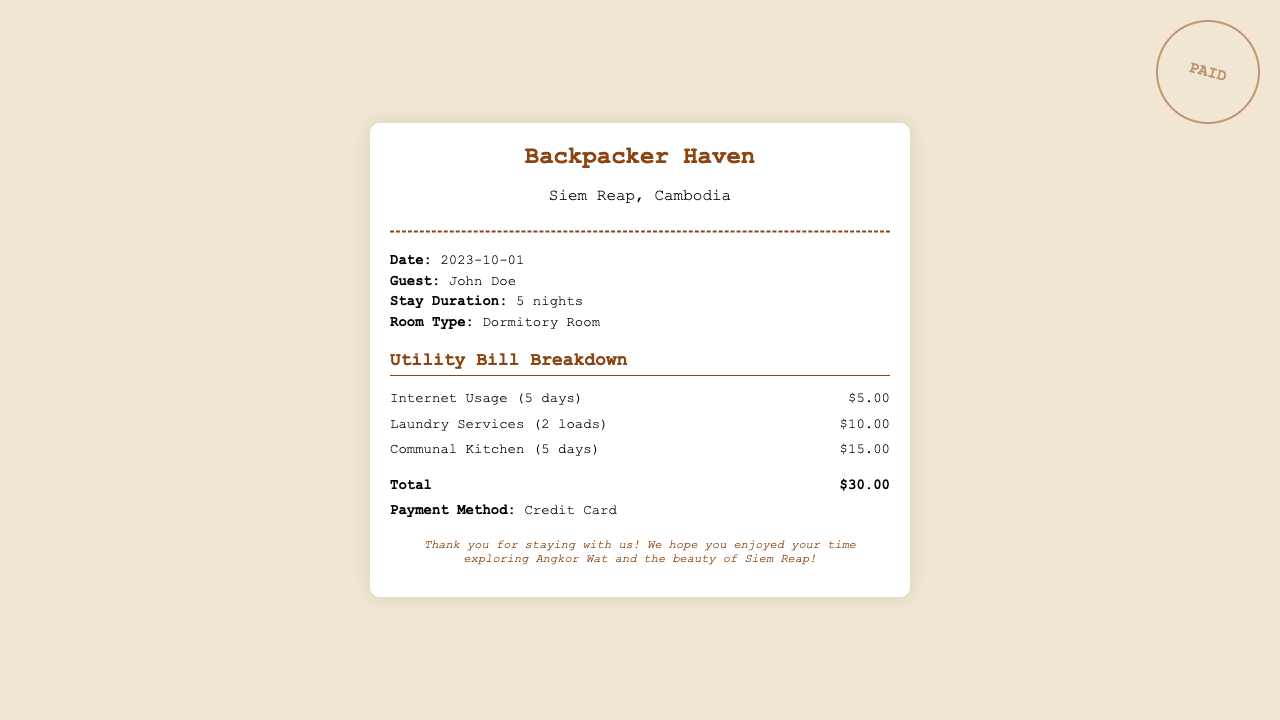What is the date of the receipt? The date is provided in the document under the info section, indicated as 2023-10-01.
Answer: 2023-10-01 How many nights did John Doe stay? The stay duration is mentioned in the info section as 5 nights.
Answer: 5 nights What is the total amount due? The total amount is calculated from the utility bill breakdown and listed at the bottom as $30.00.
Answer: $30.00 How much was charged for internet usage? The internet usage cost is detailed in the utility bill breakdown as $5.00 for 5 days.
Answer: $5.00 How many loads of laundry were done? The laundry services section indicates that 2 loads were washed, as specified in the utility bill breakdown.
Answer: 2 loads What is the payment method? The payment method is recorded in the info section, stating that it was done via Credit Card.
Answer: Credit Card How much was charged for the communal kitchen? The charge for the communal kitchen is clearly listed in the utility bill breakdown as $15.00 for 5 days.
Answer: $15.00 What type of room did John stay in? The type of room is specified in the info section as Dormitory Room.
Answer: Dormitory Room What is the name of the hostel? The name of the hostel is presented in the header at the top of the document as Backpacker Haven.
Answer: Backpacker Haven 